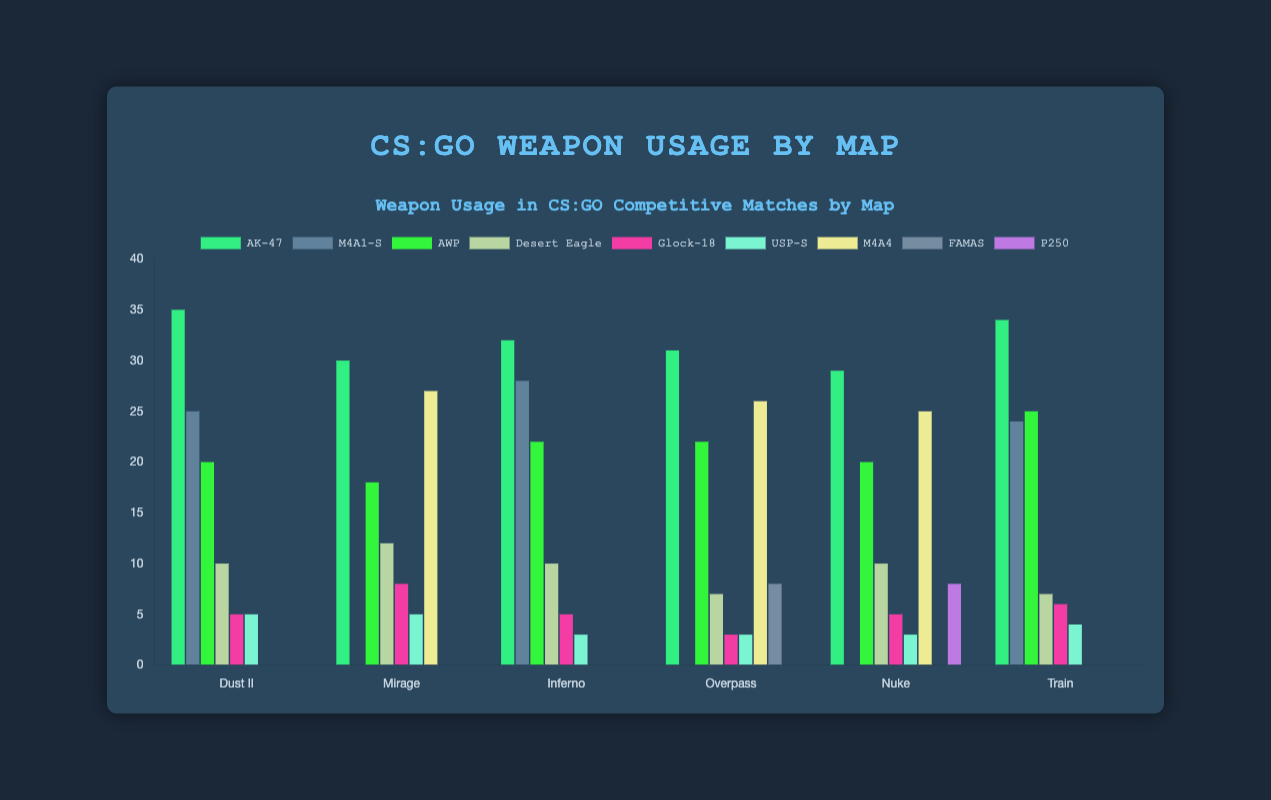Which weapon has the highest usage percentage on Dust II? By looking at the grouped bar chart, we can see which weapon has the tallest bar for Dust II. The AK-47 has the tallest bar on Dust II at 35%.
Answer: AK-47 Which map shows the highest usage of AWP? By identifying the tallest bar for AWP across all maps, we see that Train has the tallest bar for AWP at 25%.
Answer: Train Compare the usage percentages of AK-47 on Dust II and Mirage. Which one is higher and by how much? The bar for AK-47 on Dust II is at 35%, and on Mirage it is at 30%. The difference is 35% - 30% = 5%. Dust II has the higher percentage.
Answer: Dust II, by 5% What is the combined usage percentage of M4A1-S on Dust II and Inferno? We add the bars for M4A1-S on Dust II (25%) and Inferno (28%), resulting in 25% + 28% = 53%.
Answer: 53% Which map has the lowest usage percentage for Glock-18? By comparing the bars for Glock-18 across all maps, we see that Overpass and Inferno both have the shortest bars at 3%.
Answer: Overpass and Inferno On which map is the Desert Eagle most used? By identifying which map has the tallest bar for Desert Eagle, we see that Mirage has the tallest bar at 12%.
Answer: Mirage Which map has the lowest overall combined usage percentage for AK-47 and USP-S? Sum the bars for AK-47 and USP-S across all maps: Dust II (40%), Mirage (35%), Inferno (35%), Overpass (34%), Nuke (32%), Train (38%). The map with the lowest combined usage is Nuke at 32%.
Answer: Nuke What is the average usage percentage of AWP across all maps? Sum the percentages of AWP from all maps (20%, 18%, 22%, 22%, 20%, 25%) and divide by the number of maps, which is 6. The sum is 127%, so the average is 127% / 6 ≈ 21.17%.
Answer: 21.17% Visualize the difference in height between the AK-47 and Glock-18 bars on Train. The bar for the AK-47 on Train is at 34%, while the bar for the Glock-18 is at 6%. The visual difference in height corresponds to 34% - 6% = 28%.
Answer: 28% 